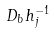Convert formula to latex. <formula><loc_0><loc_0><loc_500><loc_500>D _ { b } h ^ { - 1 } _ { j }</formula> 